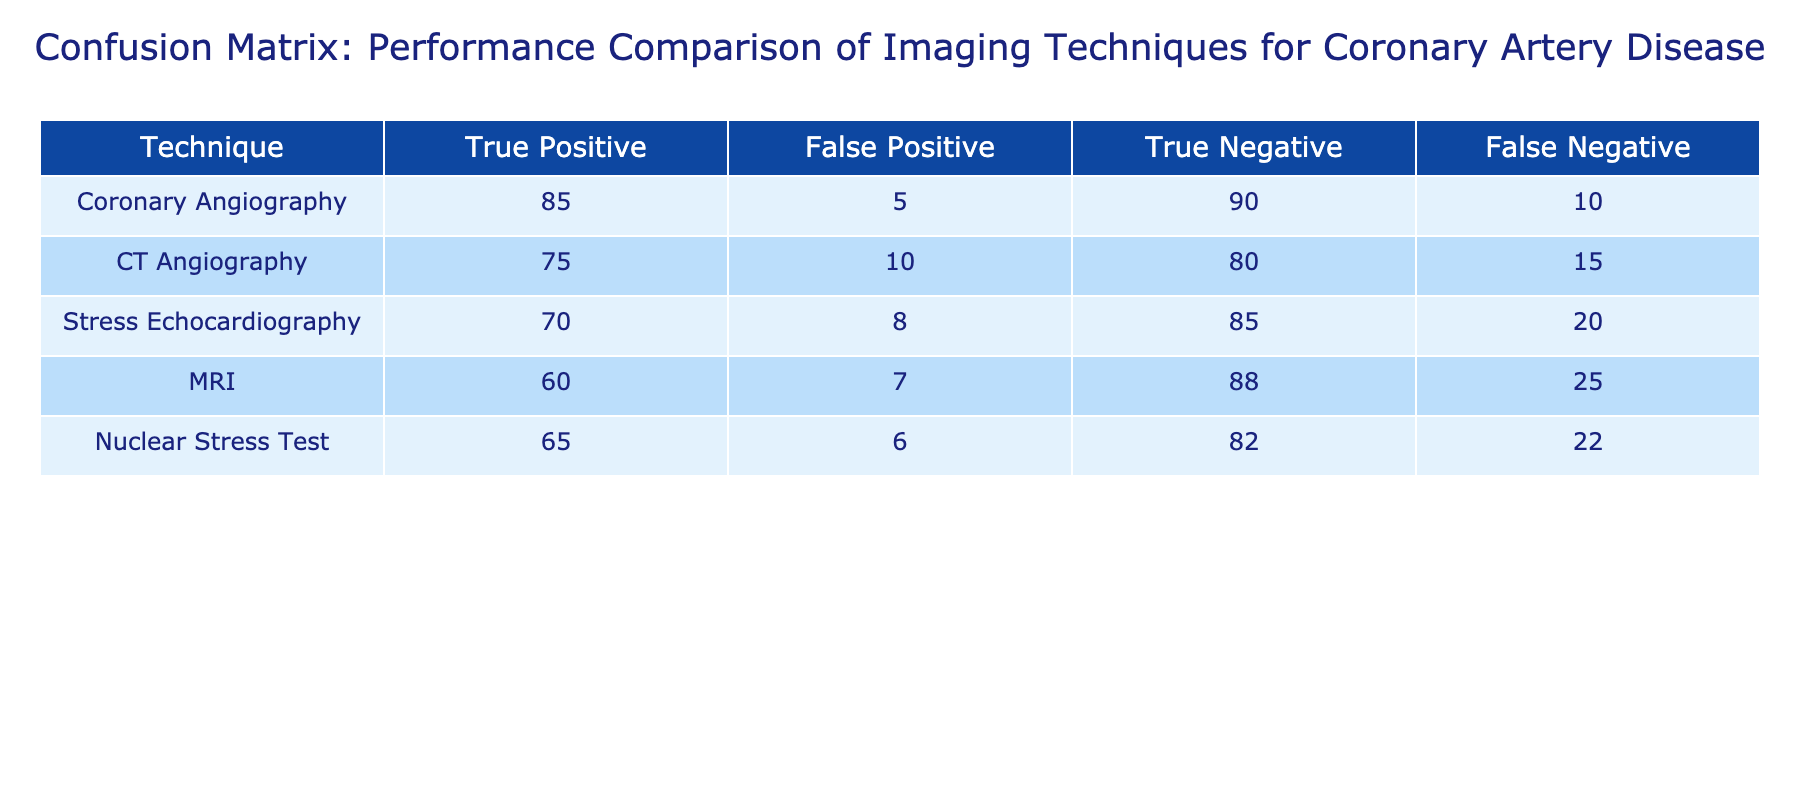What is the true positive rate for Coronary Angiography? The true positive rate is calculated by dividing the number of true positives by the sum of true positives and false negatives. For Coronary Angiography, the true positives are 85 and the false negatives are 10. Therefore, the true positive rate is 85 / (85 + 10) = 85 / 95 = 0.8947, or about 89.47%.
Answer: 89.47% Which imaging technique has the highest number of true negatives? By examining the True Negative column, the highest value is 90 for Coronary Angiography.
Answer: Coronary Angiography Is it true that MRI has more false positives than the Nuclear Stress Test? By looking at the False Positive column, MRI has 7 false positives, while the Nuclear Stress Test has 6 false positives. Since 7 is greater than 6, the statement is false.
Answer: No What is the total number of false negatives across all techniques? To find the total false negatives, we sum the False Negative values from all techniques: 10 (Coronary Angiography) + 15 (CT Angiography) + 20 (Stress Echocardiography) + 25 (MRI) + 22 (Nuclear Stress Test) = 102.
Answer: 102 Which technique has the best performance based on the combination of true positives and true negatives? We can assess performance by adding true positives and true negatives for each technique: Coronary Angiography (85 + 90 = 175), CT Angiography (75 + 80 = 155), Stress Echocardiography (70 + 85 = 155), MRI (60 + 88 = 148), and Nuclear Stress Test (65 + 82 = 147). Coronary Angiography has the highest total of 175.
Answer: Coronary Angiography 